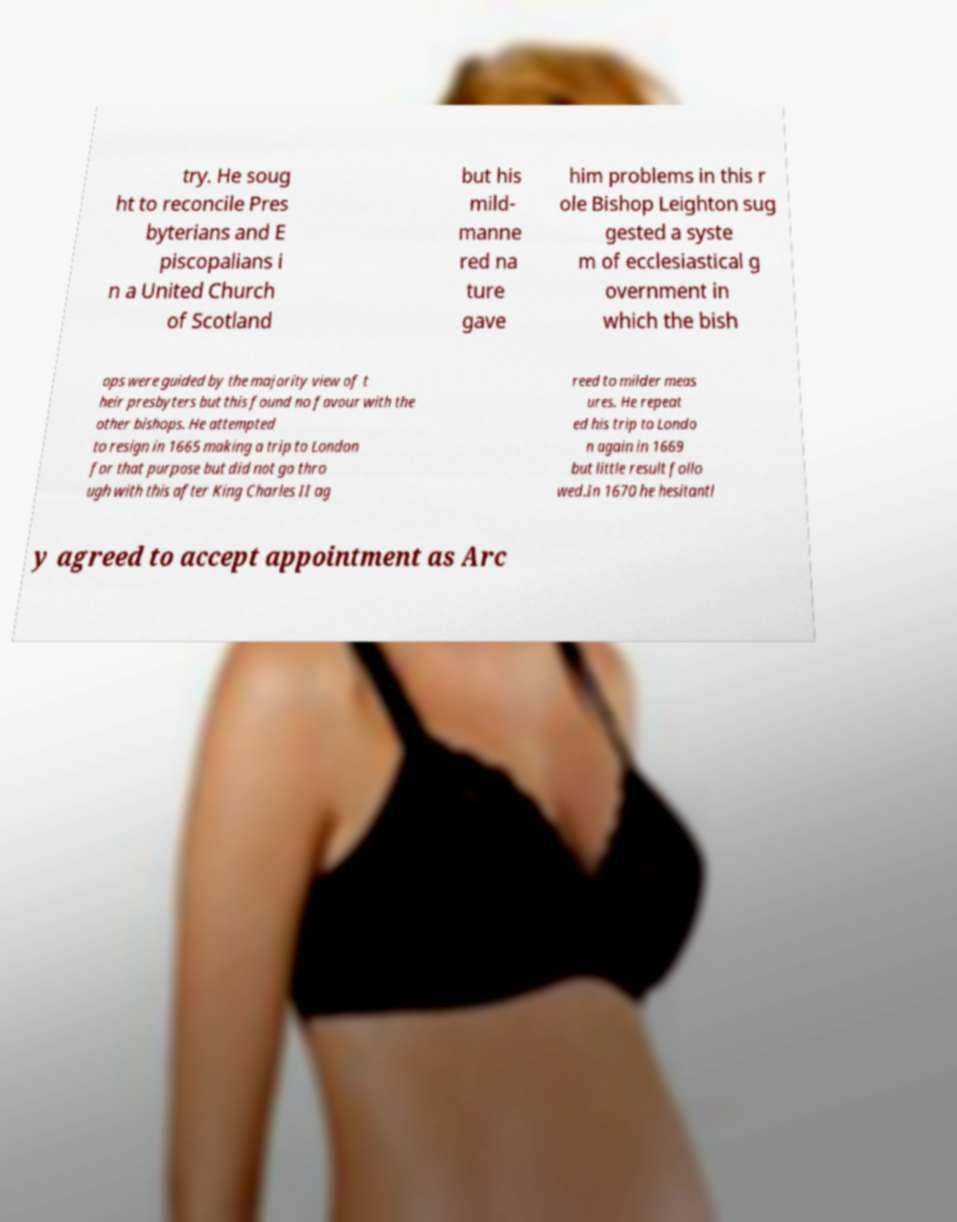Can you read and provide the text displayed in the image?This photo seems to have some interesting text. Can you extract and type it out for me? try. He soug ht to reconcile Pres byterians and E piscopalians i n a United Church of Scotland but his mild- manne red na ture gave him problems in this r ole Bishop Leighton sug gested a syste m of ecclesiastical g overnment in which the bish ops were guided by the majority view of t heir presbyters but this found no favour with the other bishops. He attempted to resign in 1665 making a trip to London for that purpose but did not go thro ugh with this after King Charles II ag reed to milder meas ures. He repeat ed his trip to Londo n again in 1669 but little result follo wed.In 1670 he hesitantl y agreed to accept appointment as Arc 